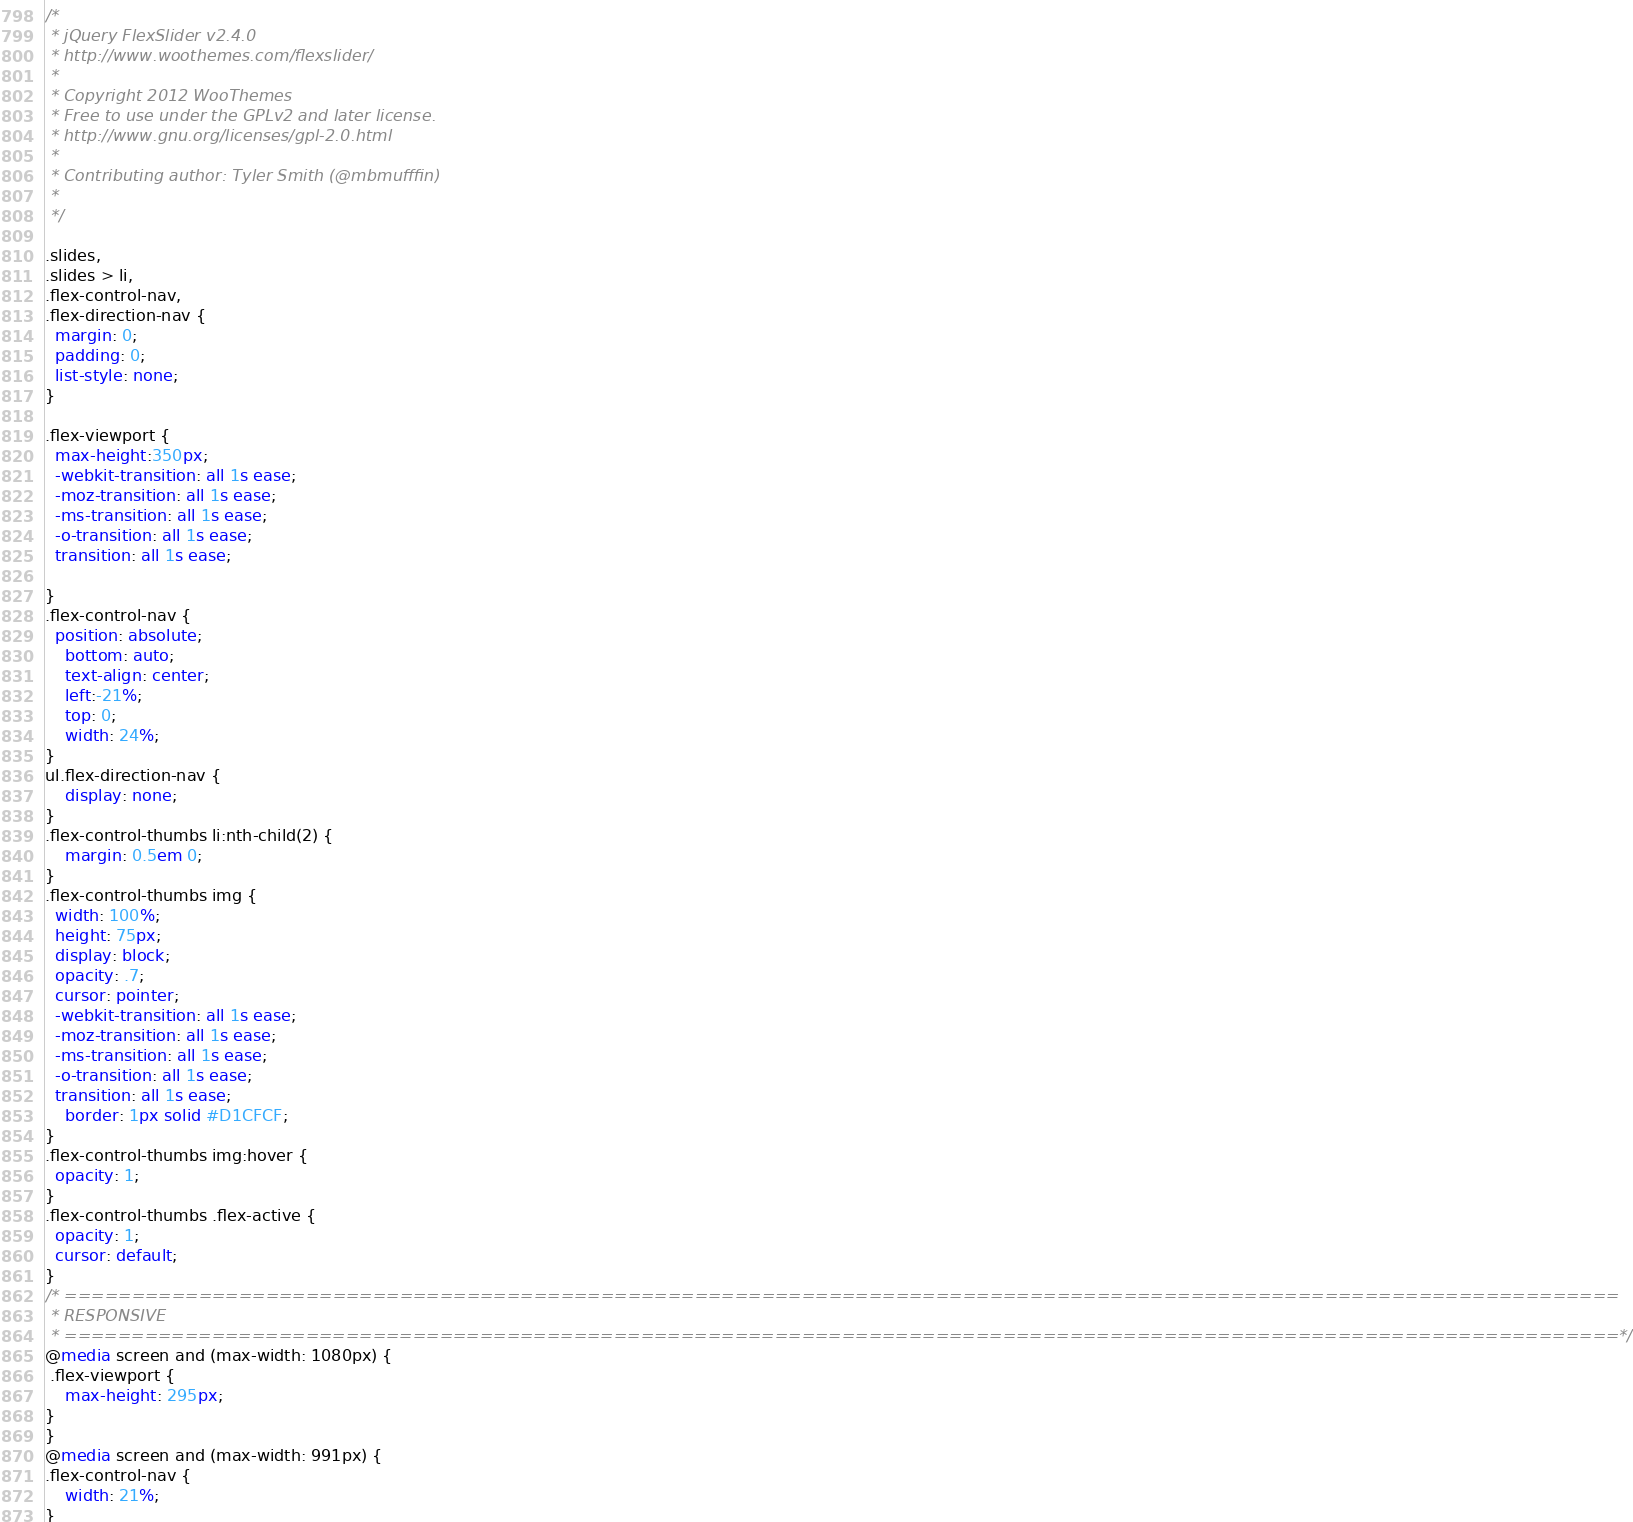Convert code to text. <code><loc_0><loc_0><loc_500><loc_500><_CSS_>/*
 * jQuery FlexSlider v2.4.0
 * http://www.woothemes.com/flexslider/
 *
 * Copyright 2012 WooThemes
 * Free to use under the GPLv2 and later license.
 * http://www.gnu.org/licenses/gpl-2.0.html
 *
 * Contributing author: Tyler Smith (@mbmufffin)
 * 
 */

.slides,
.slides > li,
.flex-control-nav,
.flex-direction-nav {
  margin: 0;
  padding: 0;
  list-style: none;
}

.flex-viewport {
  max-height:350px;
  -webkit-transition: all 1s ease;
  -moz-transition: all 1s ease;
  -ms-transition: all 1s ease;
  -o-transition: all 1s ease;
  transition: all 1s ease;

}
.flex-control-nav {
  position: absolute;
    bottom: auto;
    text-align: center;
    left:-21%;
    top: 0;
    width: 24%;
}
ul.flex-direction-nav {
    display: none;
}
.flex-control-thumbs li:nth-child(2) {
    margin: 0.5em 0;
}
.flex-control-thumbs img {
  width: 100%;
  height: 75px;
  display: block;
  opacity: .7;
  cursor: pointer;
  -webkit-transition: all 1s ease;
  -moz-transition: all 1s ease;
  -ms-transition: all 1s ease;
  -o-transition: all 1s ease;
  transition: all 1s ease;
    border: 1px solid #D1CFCF;
}
.flex-control-thumbs img:hover {
  opacity: 1;
}
.flex-control-thumbs .flex-active {
  opacity: 1;
  cursor: default;
}
/* ====================================================================================================================
 * RESPONSIVE
 * ====================================================================================================================*/
@media screen and (max-width: 1080px) {
 .flex-viewport {
    max-height: 295px;
}
}
@media screen and (max-width: 991px) {
.flex-control-nav {
    width: 21%;
}</code> 